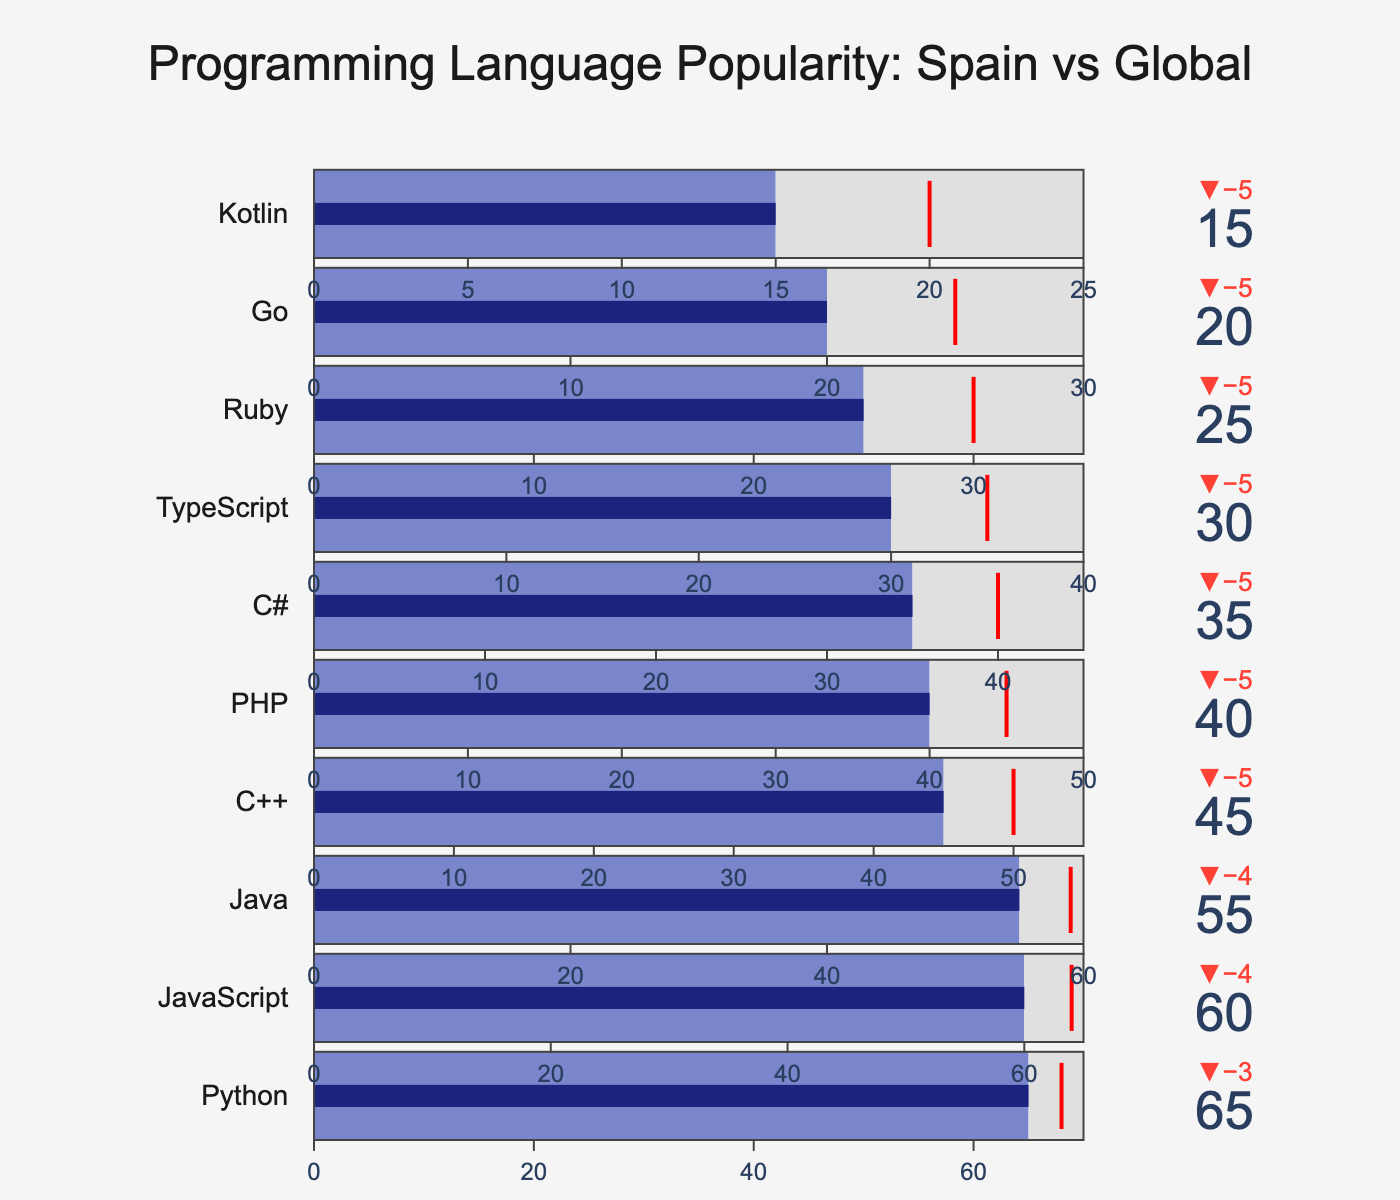What is the title of the figure? The title of the figure is located at the top center and is written in a noticeable size and color.
Answer: Programming Language Popularity: Spain vs Global How many programming languages are displayed on the chart? Count each individual bullet chart within the entire figure.
Answer: 10 Which programming language has the highest usage in Spain? Observe each bullet chart to find the one with the highest "Spain Usage" value.
Answer: Python How does the usage of Python in Spain compare to the global usage? Look at the bullet chart for Python and compare the "Spain Usage" value to the "Global Usage" value indicated by the red line.
Answer: Spain usage is 3% less than global usage Which programming language is used equally in Spain and globally? Identify any bullet chart where the "Spain Usage" value matches the "Global Usage" marked by the red line exactly.
Answer: None What is the difference in the target usage value between C++ and PHP? Check the 'Target' values for C++ and PHP and calculate the difference between them.
Answer: The difference is 5 (55 for C++ and 50 for PHP) How much greater is the global usage of JavaScript compared to the Spain usage of PHP? Compare the "Global Usage" value of JavaScript with the "Spain Usage" value of PHP by subtracting the latter from the former.
Answer: The global usage of JavaScript is 24% greater than the Spain usage of PHP Which programming language has the smallest difference between Spain usage and its target value? Calculate the difference between the "Spain Usage" and "Target" for each programming language and find the smallest one.
Answer: Python (difference of 5%) List all programming languages that have a Spain usage of 30 or less. Look for programming languages whose "Spain Usage" value is 30 or below.
Answer: TypeScript, Ruby, Go, Kotlin What is the combined Spain usage of the three least popular programming languages? Identify the three programming languages with the lowest "Spain Usage" values and sum those values.
Answer: The combined Spain usage is 70 (Kotlin: 15, Go: 20, Ruby: 25) 